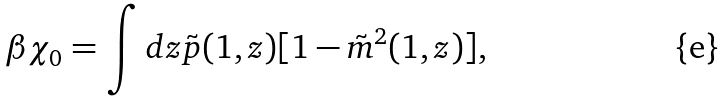<formula> <loc_0><loc_0><loc_500><loc_500>\beta \chi _ { 0 } = \int d z \tilde { p } ( 1 , z ) [ 1 - \tilde { m } ^ { 2 } ( 1 , z ) ] ,</formula> 